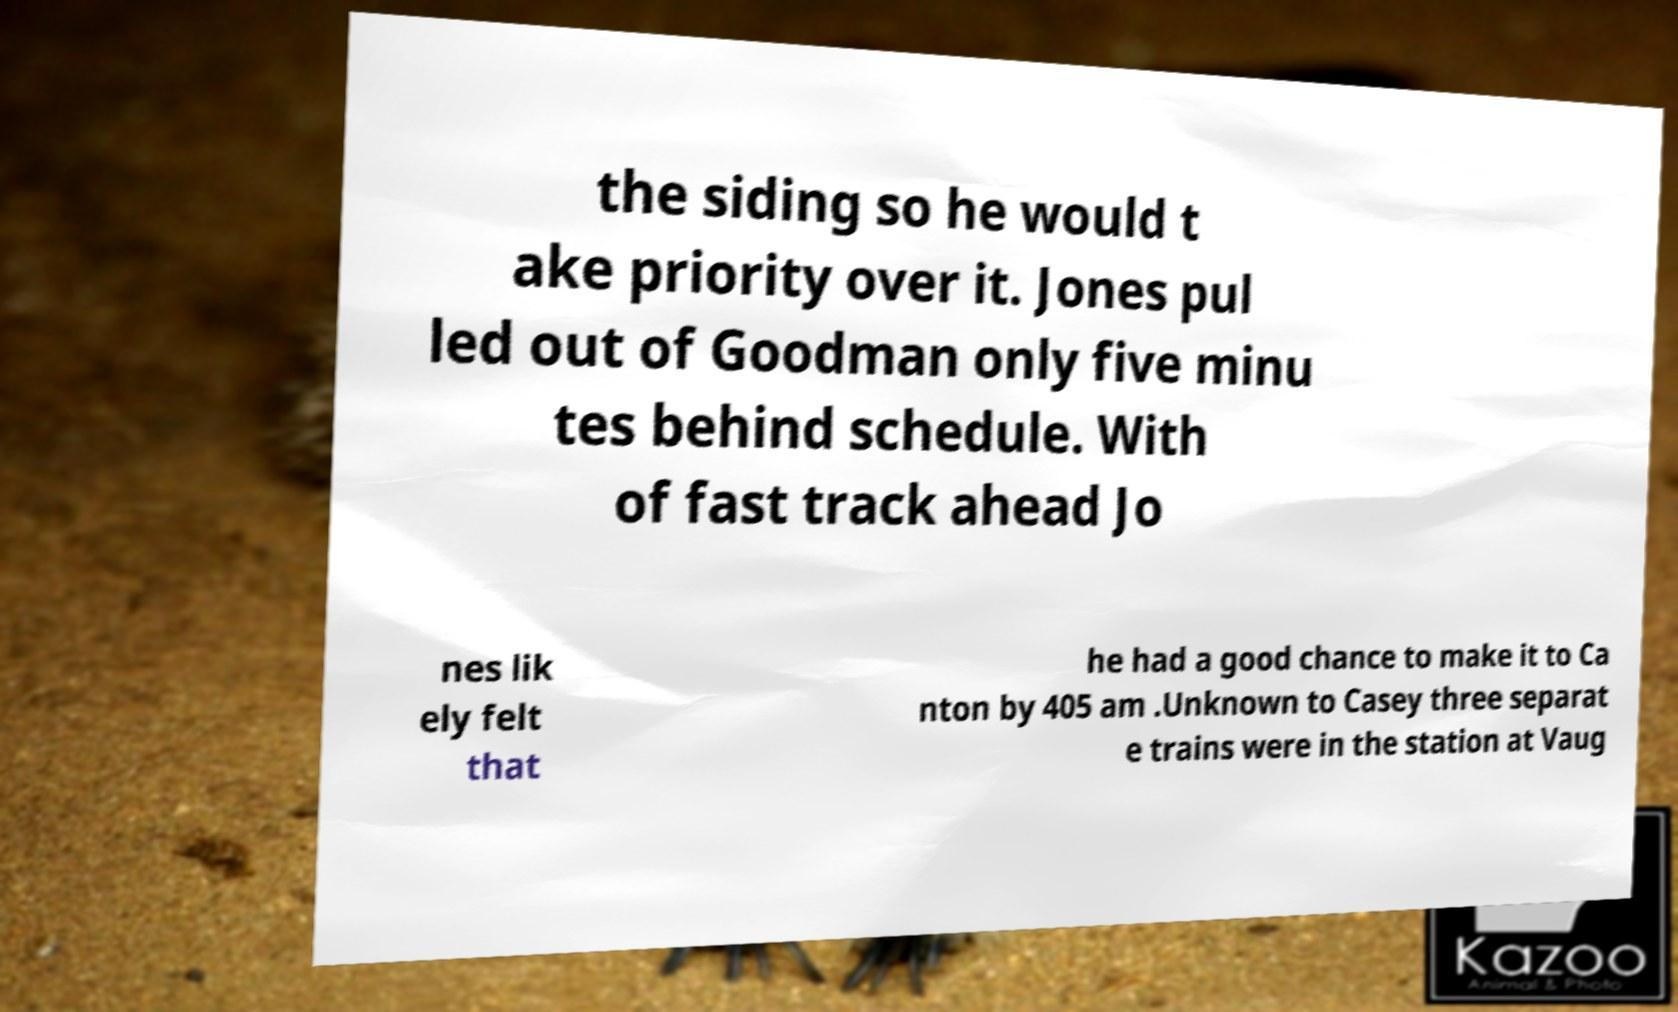Please identify and transcribe the text found in this image. the siding so he would t ake priority over it. Jones pul led out of Goodman only five minu tes behind schedule. With of fast track ahead Jo nes lik ely felt that he had a good chance to make it to Ca nton by 405 am .Unknown to Casey three separat e trains were in the station at Vaug 